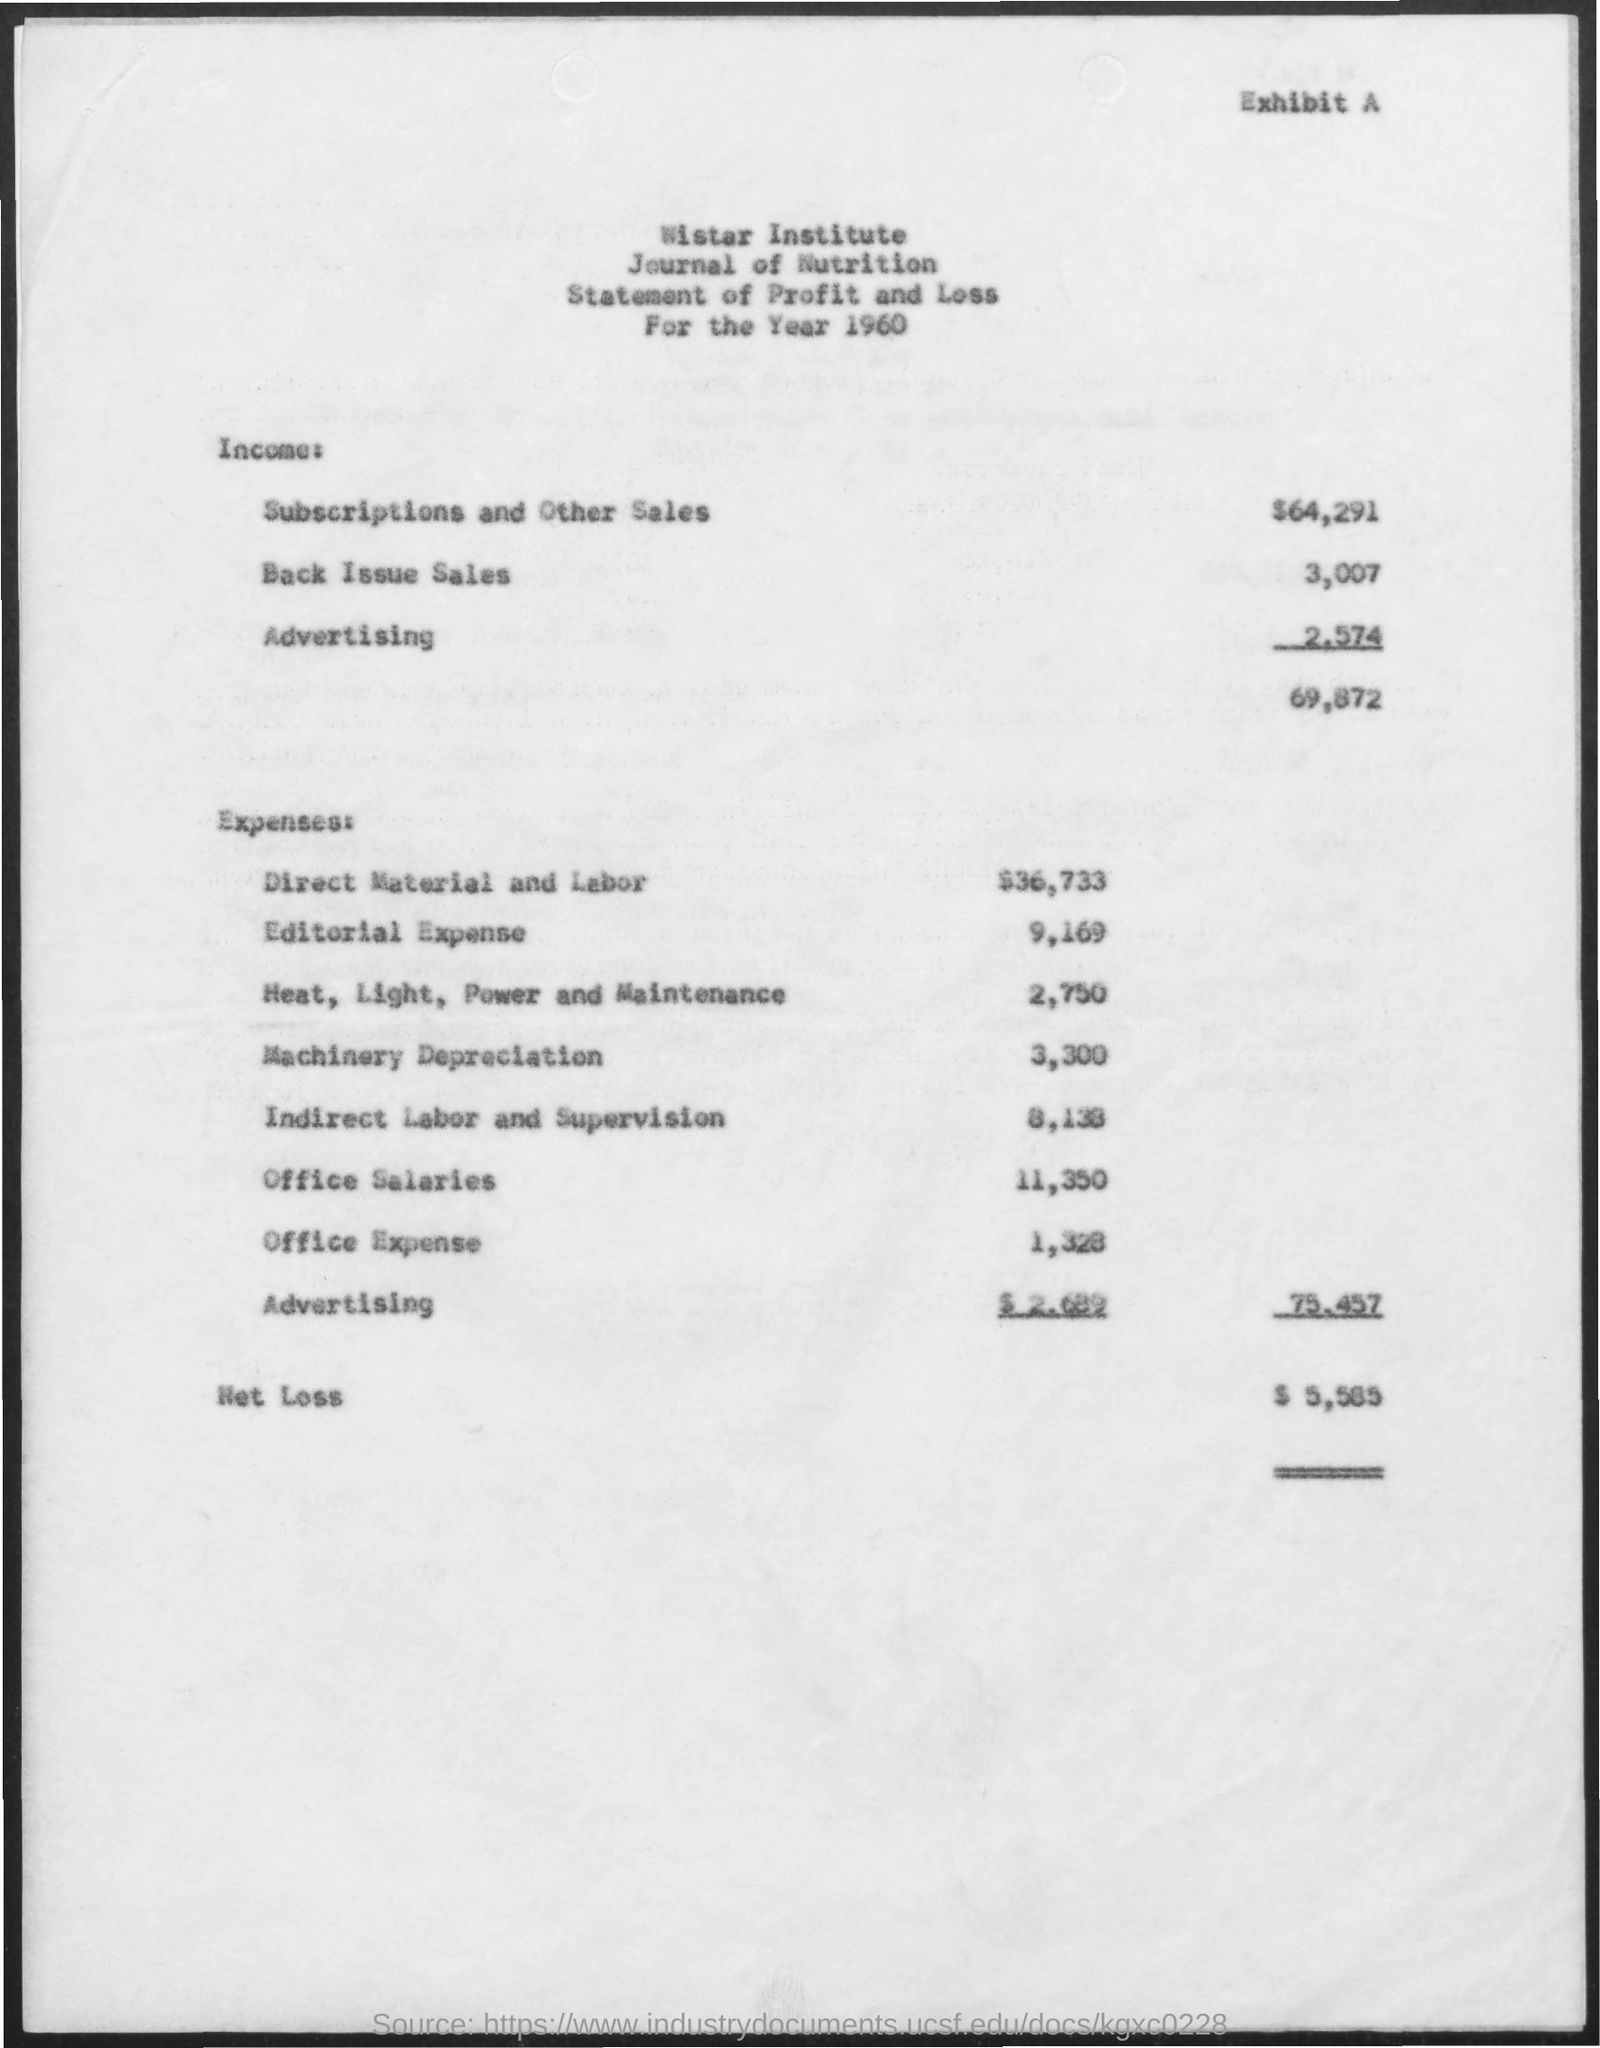What is the net loss?
Provide a short and direct response. $ 5,585. What is the office expense?
Your answer should be very brief. 1,328. What is the income from subscriptions and other sales?
Provide a succinct answer. $64,291. What is the income from back issue sales?
Keep it short and to the point. 3,007. 